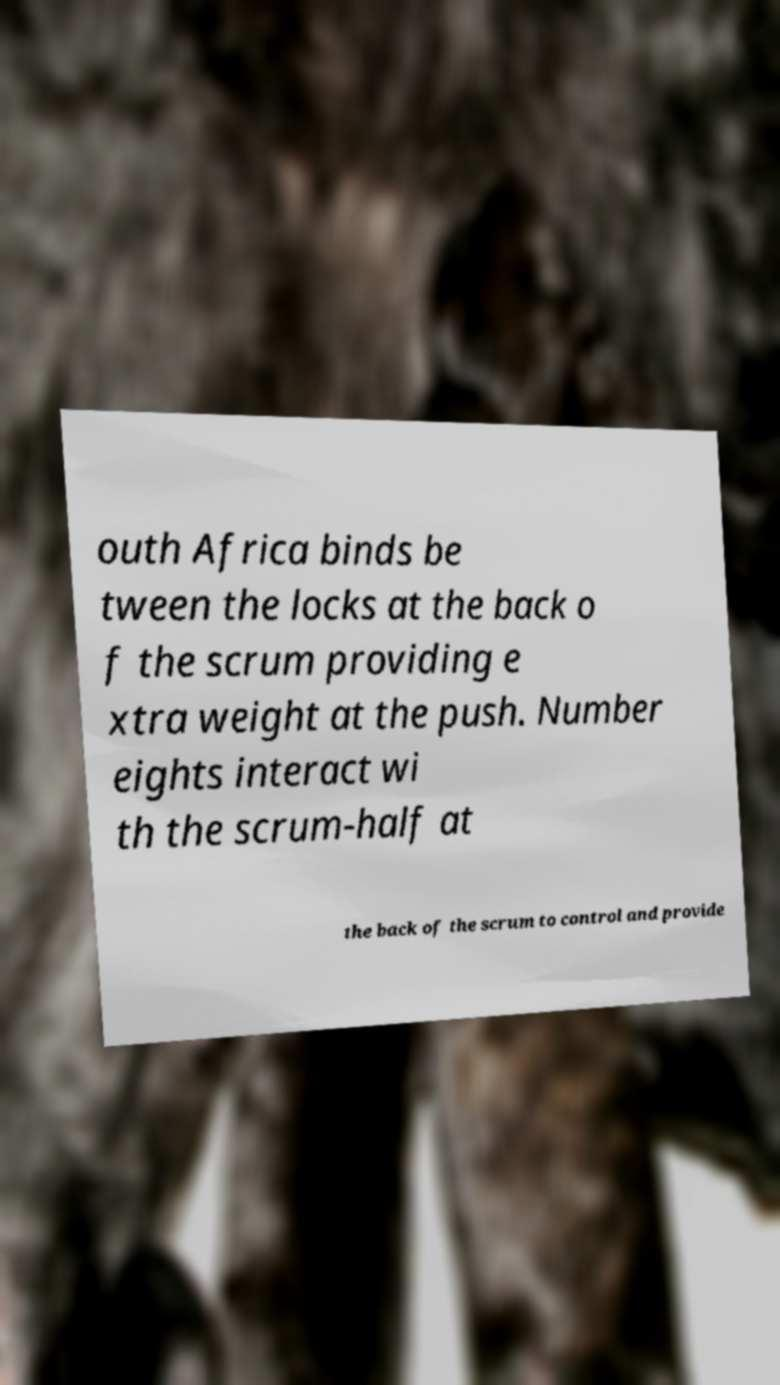I need the written content from this picture converted into text. Can you do that? outh Africa binds be tween the locks at the back o f the scrum providing e xtra weight at the push. Number eights interact wi th the scrum-half at the back of the scrum to control and provide 